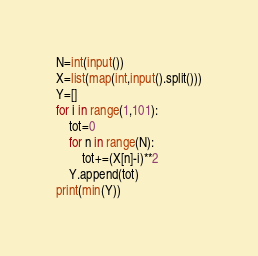Convert code to text. <code><loc_0><loc_0><loc_500><loc_500><_Python_>N=int(input())
X=list(map(int,input().split()))
Y=[]
for i in range(1,101):
    tot=0
    for n in range(N):
        tot+=(X[n]-i)**2
    Y.append(tot)
print(min(Y))</code> 